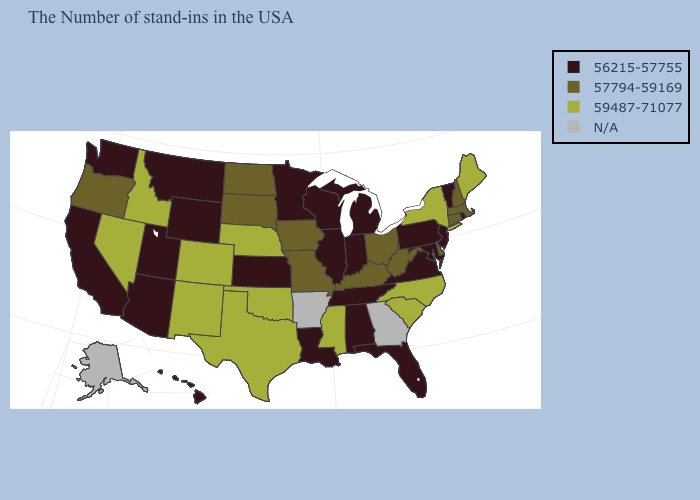What is the value of Maryland?
Quick response, please. 56215-57755. Does Nebraska have the highest value in the MidWest?
Short answer required. Yes. What is the value of Louisiana?
Concise answer only. 56215-57755. Does Pennsylvania have the highest value in the Northeast?
Keep it brief. No. Which states have the lowest value in the USA?
Short answer required. Rhode Island, Vermont, New Jersey, Maryland, Pennsylvania, Virginia, Florida, Michigan, Indiana, Alabama, Tennessee, Wisconsin, Illinois, Louisiana, Minnesota, Kansas, Wyoming, Utah, Montana, Arizona, California, Washington, Hawaii. What is the highest value in the USA?
Give a very brief answer. 59487-71077. Which states have the highest value in the USA?
Short answer required. Maine, New York, North Carolina, South Carolina, Mississippi, Nebraska, Oklahoma, Texas, Colorado, New Mexico, Idaho, Nevada. Does Kentucky have the lowest value in the South?
Be succinct. No. Is the legend a continuous bar?
Be succinct. No. Name the states that have a value in the range N/A?
Concise answer only. Georgia, Arkansas, Alaska. Which states hav the highest value in the Northeast?
Keep it brief. Maine, New York. Name the states that have a value in the range N/A?
Give a very brief answer. Georgia, Arkansas, Alaska. Name the states that have a value in the range 57794-59169?
Keep it brief. Massachusetts, New Hampshire, Connecticut, Delaware, West Virginia, Ohio, Kentucky, Missouri, Iowa, South Dakota, North Dakota, Oregon. What is the value of Connecticut?
Short answer required. 57794-59169. 